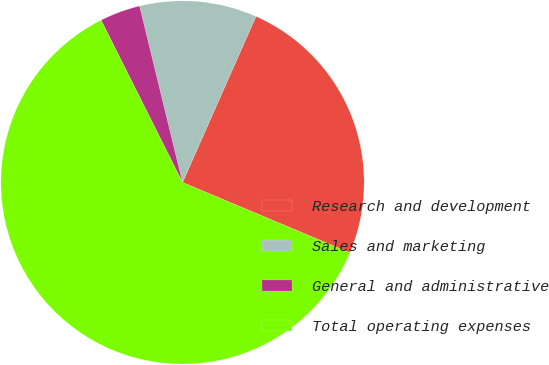<chart> <loc_0><loc_0><loc_500><loc_500><pie_chart><fcel>Research and development<fcel>Sales and marketing<fcel>General and administrative<fcel>Total operating expenses<nl><fcel>24.7%<fcel>10.43%<fcel>3.6%<fcel>61.27%<nl></chart> 